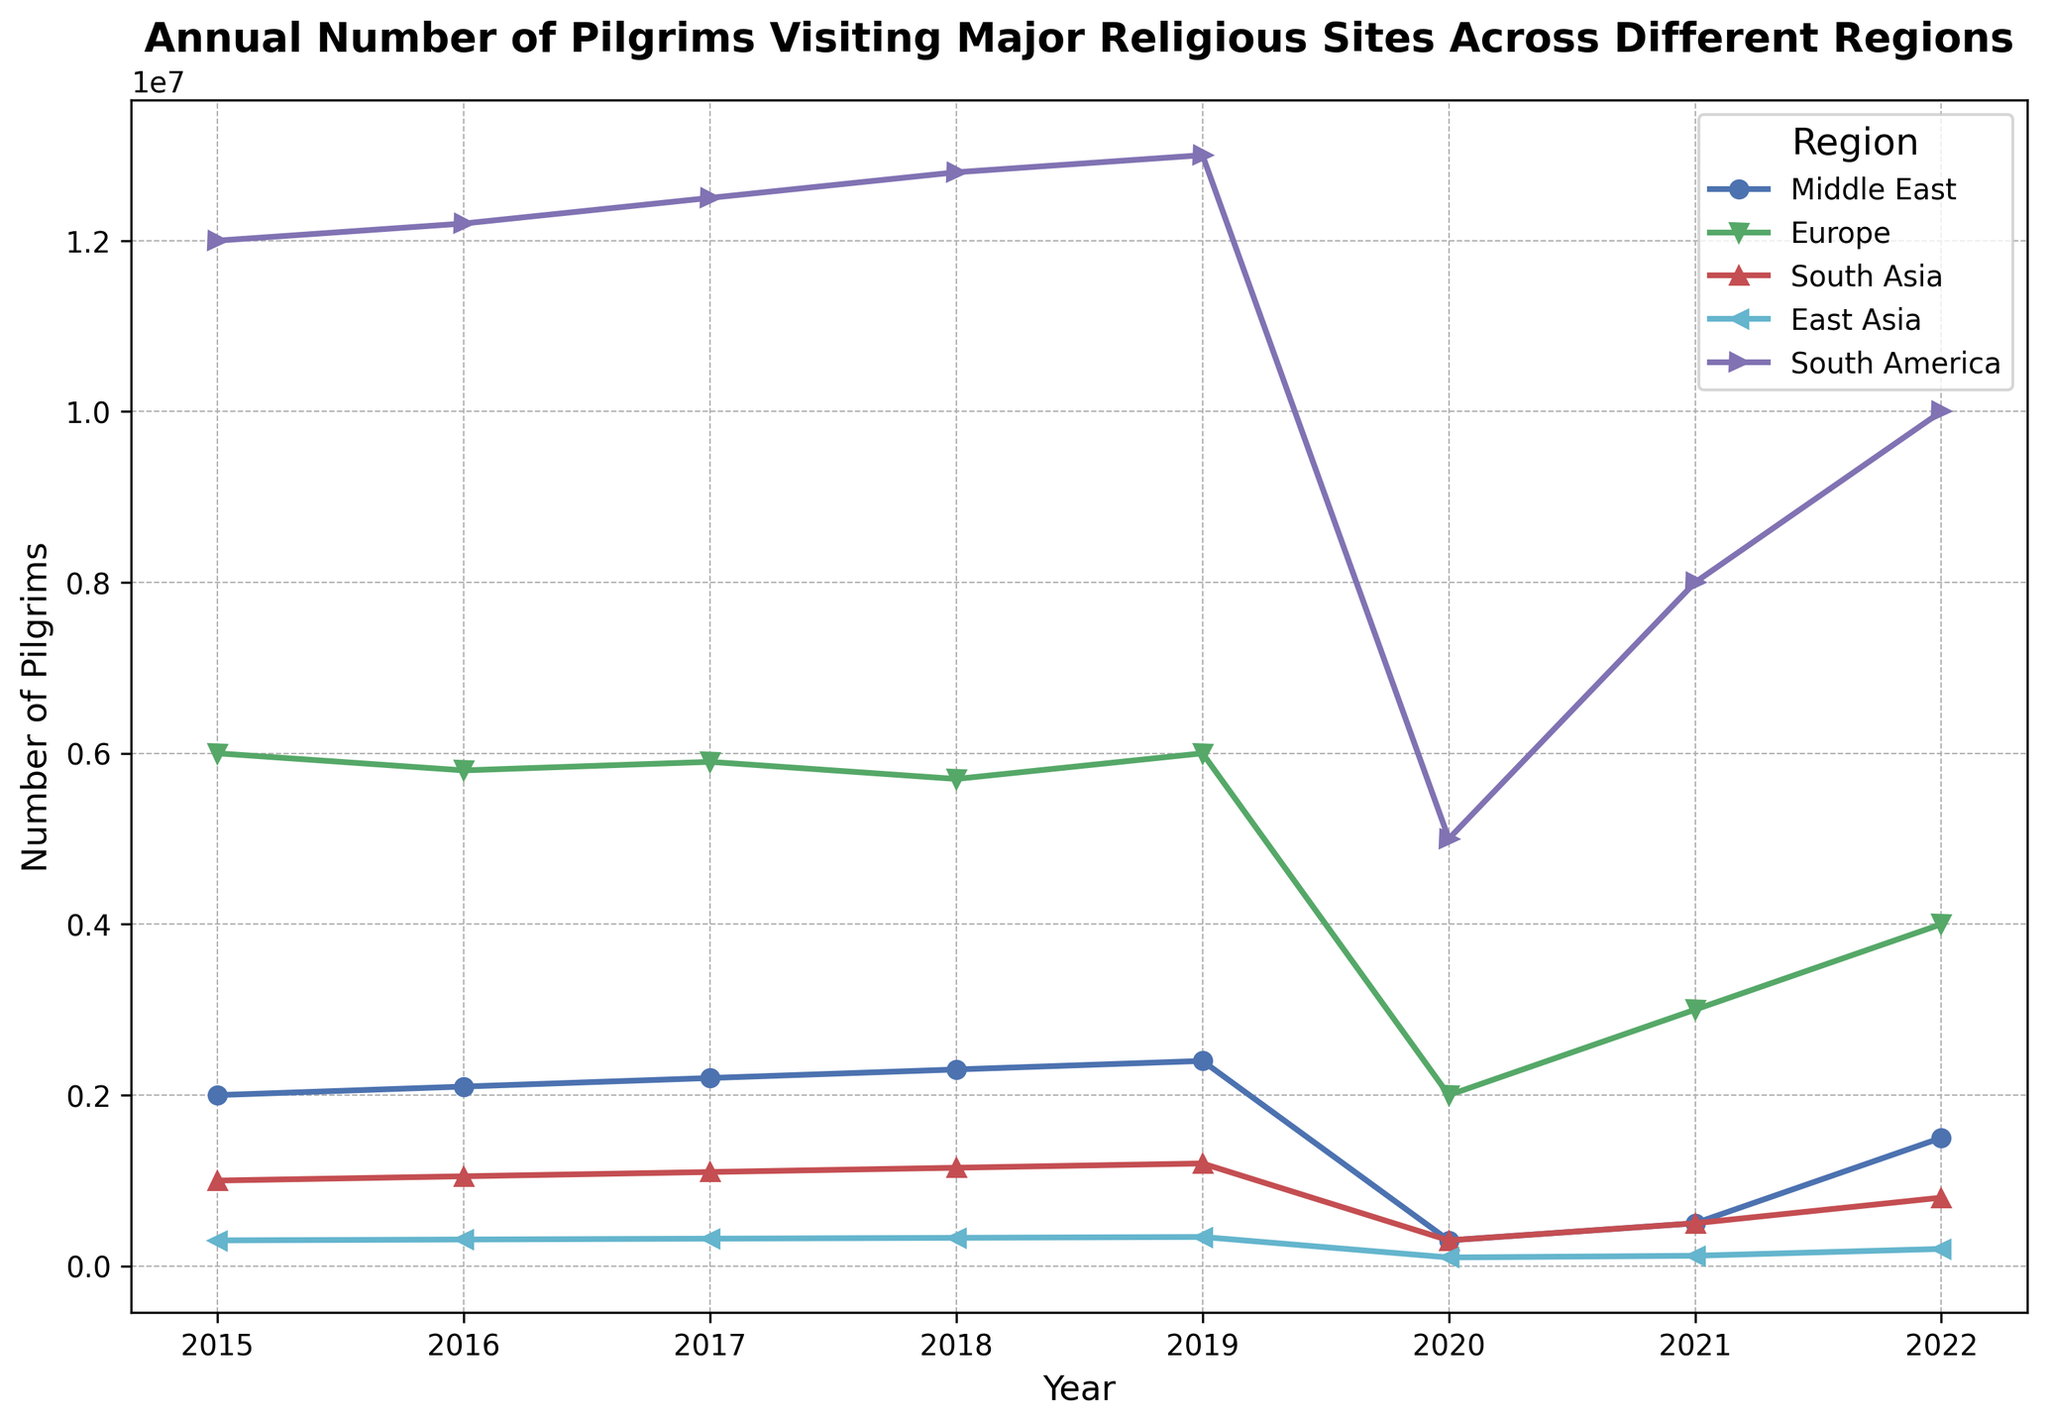What is the overall trend of the number of pilgrims visiting Mecca from 2015 to 2022? The plotted line for Mecca in the Middle East region shows an increasing trend from 2015 to 2019, a sharp decline in 2020, a slight increase in 2021, and a major increase in 2022.
Answer: Increase, sharp decline, then recovery In which year did Aparecida in South America experience the maximum number of pilgrims, and how many pilgrims were there? The highest point on the line for Aparecida in South America occurs in 2019 with a visible peak at the label showing 13,000,000 pilgrims.
Answer: 2019, 13,000,000 How did the number of pilgrims visiting Lourdes in Europe change between 2017 and 2020? The line for Lourdes shows a decrease from 5,900,000 in 2017 to a significant drop to 2,000,000 in 2020.
Answer: Decreased significantly Compare the number of pilgrims visiting Varanasi in South Asia and Kumano Kodo in East Asia in 2020. In 2020, the line for Varanasi intersects at 300,000, and the line for Kumano Kodo intersects at 100,000.
Answer: Varanasi: 300,000, Kumano Kodo: 100,000 What was the total number of pilgrims visiting Mecca from 2015 to 2019? Summing the values for Mecca from 2015 to 2019: 2,000,000 + 2,100,000 + 2,200,000 + 2,300,000 + 2,400,000 equals 11,000,000.
Answer: 11,000,000 Which region experienced the most dramatic decline in the number of pilgrims in 2020? Comparing the lines, Aparecida in South America shows a sharp drop from 13,000,000 in 2019 to 5,000,000 in 2020, the steepest decline.
Answer: South America Which region had the highest average number of pilgrims per year from 2015 to 2019? Calculate the average for each region from 2015 to 2019 and compare:
Mecca: (2,000,000+2,100,000+2,200,000+2,300,000+2,400,000)/5 = 2,200,000
Lourdes: (6,000,000+5,800,000+5,900,000+5,700,000+6,000,000)/5 = 5,880,000
Varanasi: (1,000,000+1,050,000+1,100,000+1,150,000+1,200,000)/5 = 1,100,000
Kumano Kodo: (300,000+310,000+320,000+330,000+340,000)/5 = 320,000
Aparecida: (12,000,000+12,200,000+12,500,000+12,800,000+13,000,000)/5 = 12,500,000
Aparecida in South America has the highest average.
Answer: South America How did the number of pilgrims visiting Kumano Kodo change from 2015 to 2018? Starting at 300,000 in 2015, the line for Kumano Kodo increases slightly each year to reach 330,000 in 2018.
Answer: Increased gradually 